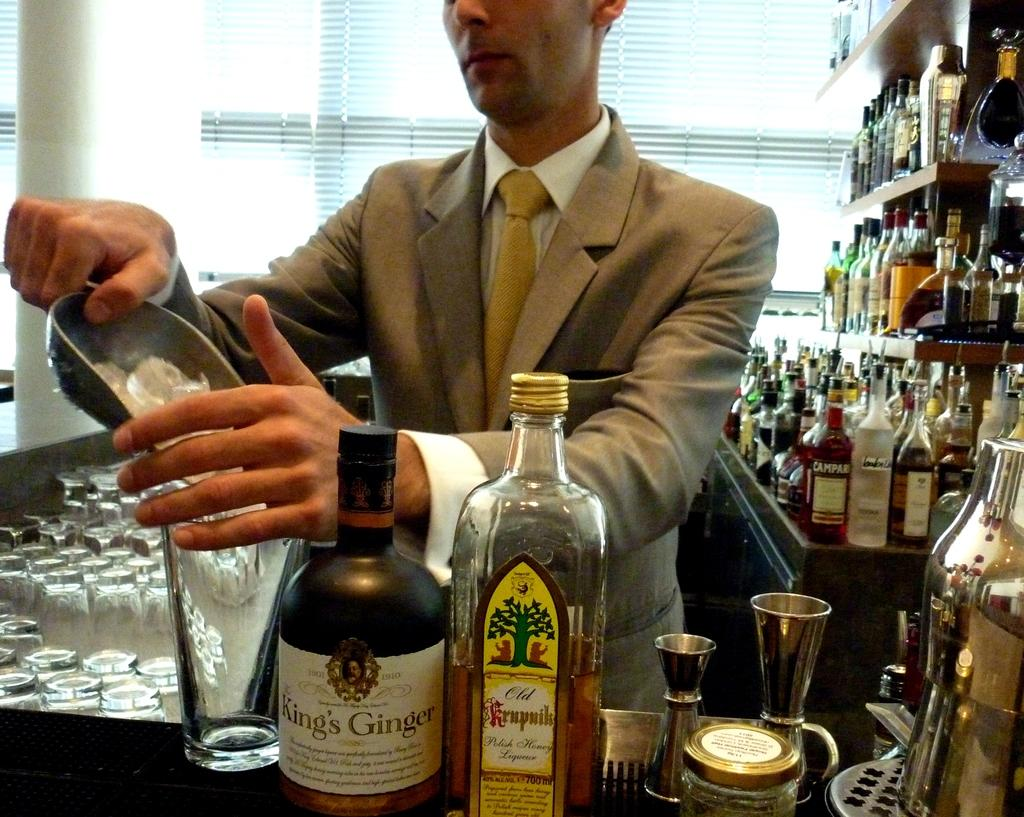<image>
Render a clear and concise summary of the photo. A bartender is making a drink next to a bottle of King's Ginger. 